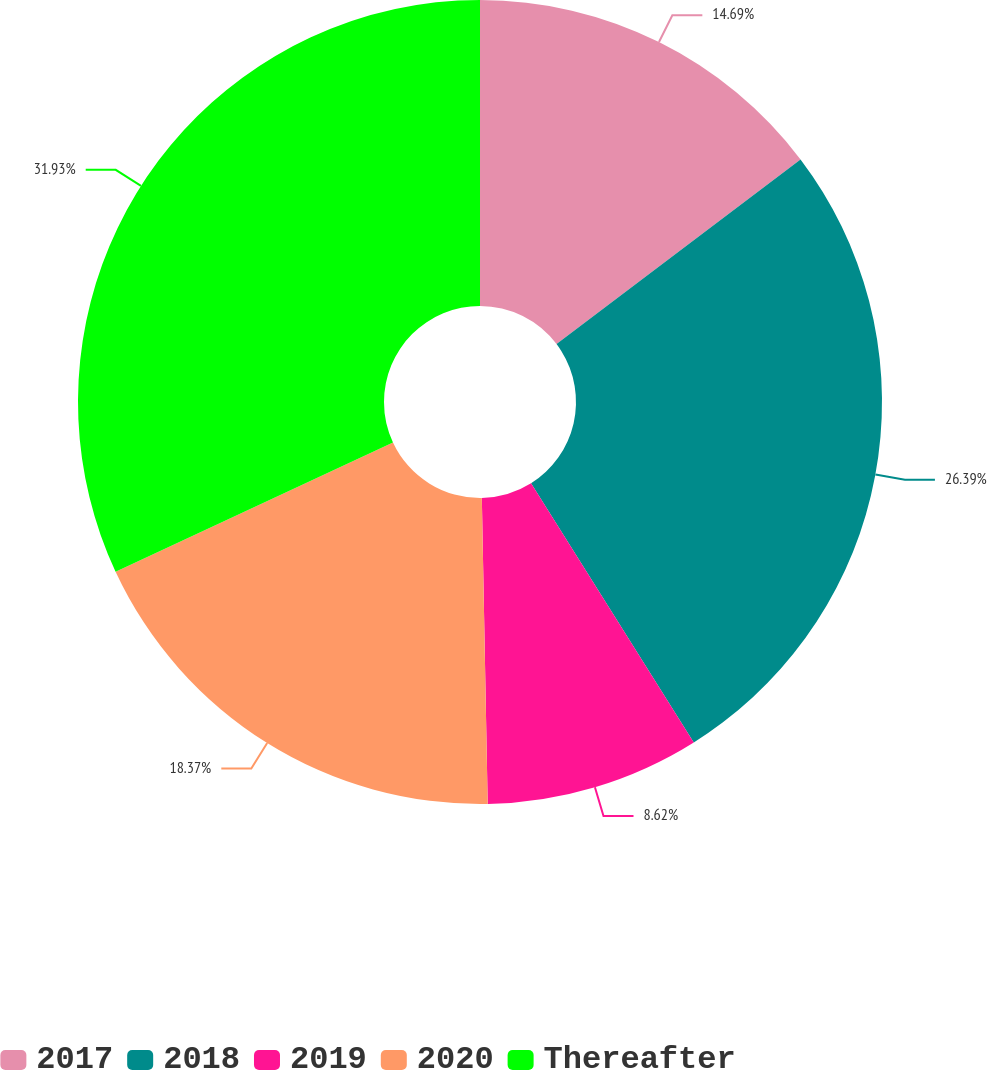Convert chart. <chart><loc_0><loc_0><loc_500><loc_500><pie_chart><fcel>2017<fcel>2018<fcel>2019<fcel>2020<fcel>Thereafter<nl><fcel>14.69%<fcel>26.39%<fcel>8.62%<fcel>18.37%<fcel>31.94%<nl></chart> 